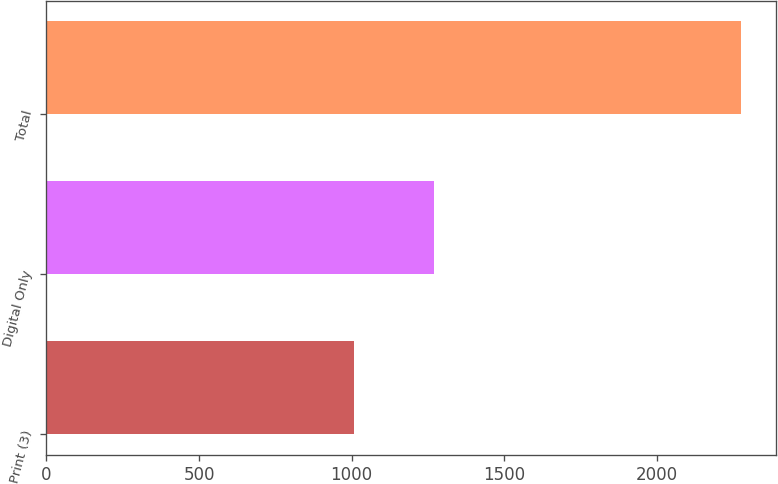Convert chart. <chart><loc_0><loc_0><loc_500><loc_500><bar_chart><fcel>Print (3)<fcel>Digital Only<fcel>Total<nl><fcel>1007<fcel>1270<fcel>2277<nl></chart> 